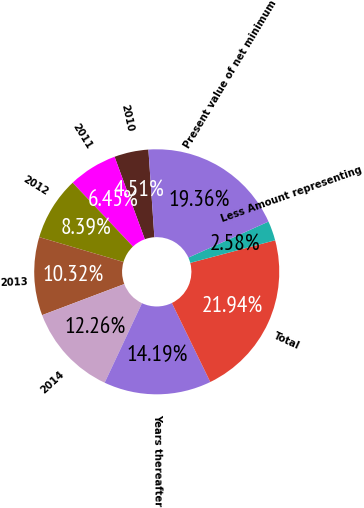Convert chart. <chart><loc_0><loc_0><loc_500><loc_500><pie_chart><fcel>2010<fcel>2011<fcel>2012<fcel>2013<fcel>2014<fcel>Years thereafter<fcel>Total<fcel>Less Amount representing<fcel>Present value of net minimum<nl><fcel>4.51%<fcel>6.45%<fcel>8.39%<fcel>10.32%<fcel>12.26%<fcel>14.19%<fcel>21.94%<fcel>2.58%<fcel>19.36%<nl></chart> 